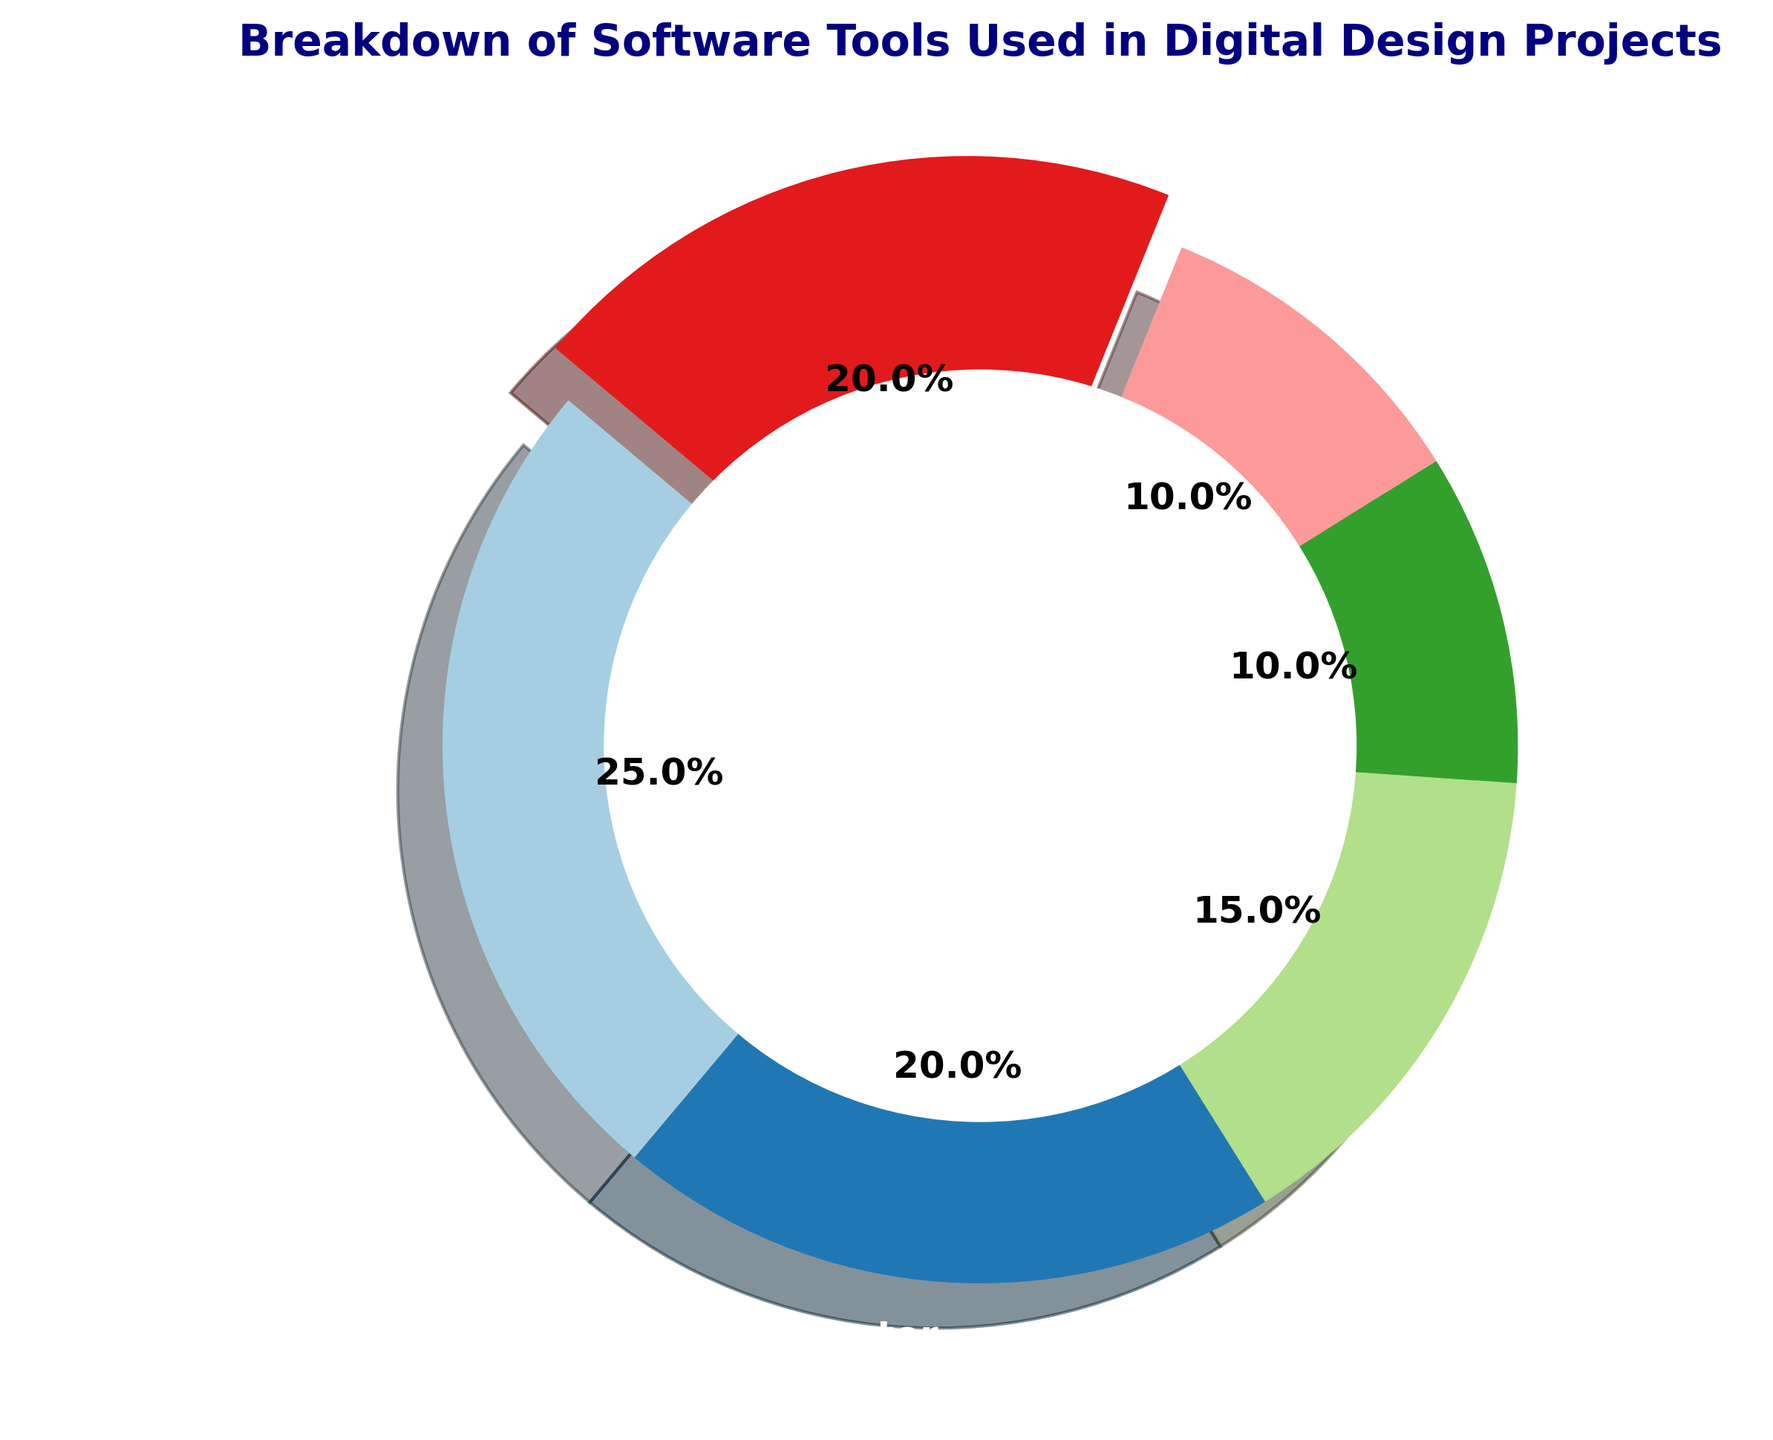what percentage of the tools used are "Other"? Look specifically for the "Other" segment in the pie chart. The percentage is displayed next to the segment.
Answer: 20% How much more is Adobe Photoshop used compared to Blender? Adobe Photoshop has a usage percentage of 25%, and Blender has 10%. Subtract Blender's percentage from Photoshop's: 25% - 10% = 15%
Answer: 15% Which two tools have the same usage percentage? By examining the pie chart, you can see that Blender and Clip Studio Paint both have a usage percentage of 10%.
Answer: Blender and Clip Studio Paint By how much is After Effects usage lower than Illustrator? Illustrator has a usage percentage of 20%, and After Effects has 15%. Subtract After Effects' percentage from Illustrator's: 20% - 15% = 5%.
Answer: 5% What is the total percentage usage of Adobe Photoshop, Illustrator, and After Effects combined? Add the usage percentages of Adobe Photoshop (25%), Illustrator (20%), and After Effects (15%): 25% + 20% + 15% = 60%
Answer: 60% Which software tool segment appears largest in the chart? The largest segment visually can be identified as Adobe Photoshop, which has the highest usage percentage at 25%.
Answer: Adobe Photoshop What is the usage difference between the least and most used tools? The least used tools are Blender and Clip Studio Paint (10%), and the most used tool is Adobe Photoshop (25%). Subtract the smallest percentage from the largest: 25% - 10% = 15%.
Answer: 15% What are the three software tools with the highest usage percentages? The three tools with the highest usage are Adobe Photoshop (25%), Illustrator (20%), and Other (20%).
Answer: Adobe Photoshop, Illustrator, Other 